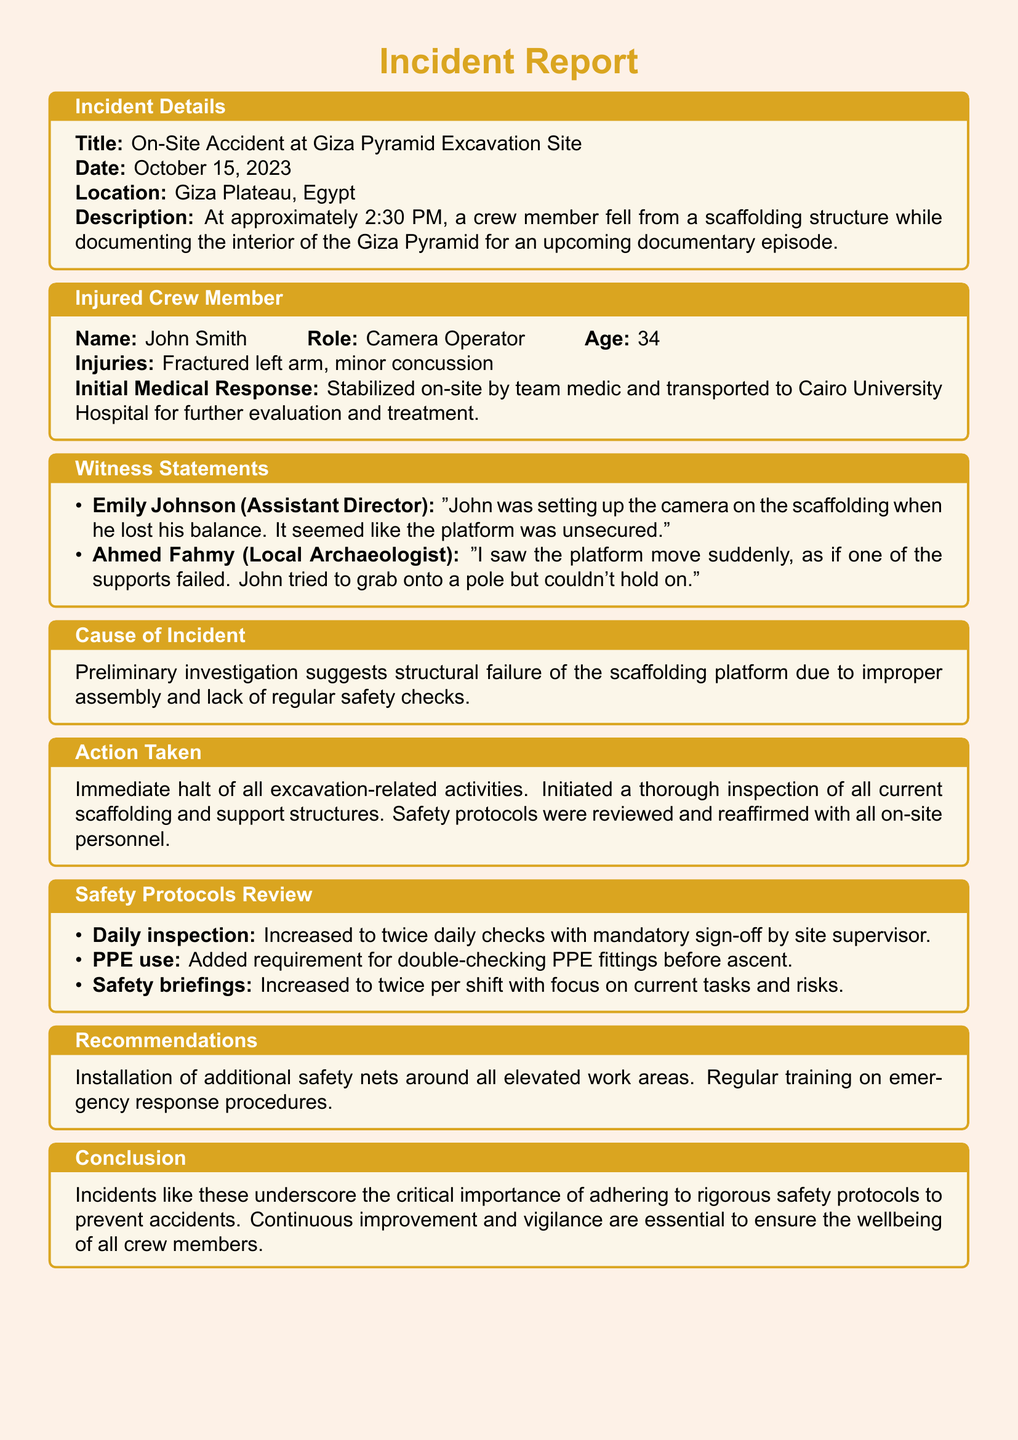What is the title of the incident report? The title of the incident report is detailed in the section labeled "Incident Details."
Answer: On-Site Accident at Giza Pyramid Excavation Site What date did the incident occur? The date of the incident is specifically mentioned in the "Incident Details" section.
Answer: October 15, 2023 Who was the injured crew member? The name of the injured crew member is listed under the "Injured Crew Member" section.
Answer: John Smith What type of injuries did the crew member sustain? The document specifies the injuries sustained in the "Injured Crew Member" section.
Answer: Fractured left arm, minor concussion What caused the incident according to the preliminary investigation? The reason for the incident is summarized in the "Cause of Incident" section.
Answer: Structural failure of the scaffolding platform What immediate action was taken following the incident? The actions taken are outlined in the "Action Taken" section.
Answer: Immediate halt of all excavation-related activities How many times will safety briefings now occur per shift? The new frequency for safety briefings is explained in the "Safety Protocols Review" section.
Answer: Twice per shift What is one of the recommendations made after the incident? Recommendations for future safety measures are provided in that section.
Answer: Installation of additional safety nets What role did John Smith have in the crew? The role of John Smith is explicitly mentioned in the "Injured Crew Member" section.
Answer: Camera Operator 